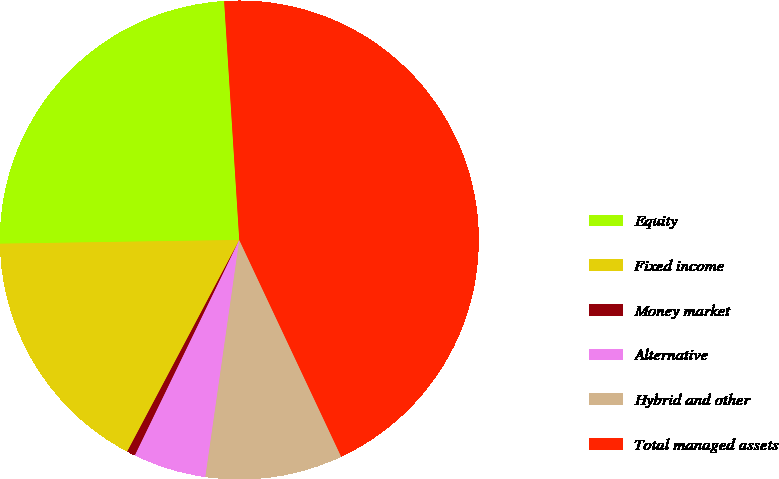Convert chart to OTSL. <chart><loc_0><loc_0><loc_500><loc_500><pie_chart><fcel>Equity<fcel>Fixed income<fcel>Money market<fcel>Alternative<fcel>Hybrid and other<fcel>Total managed assets<nl><fcel>24.24%<fcel>17.0%<fcel>0.57%<fcel>4.92%<fcel>9.26%<fcel>44.01%<nl></chart> 